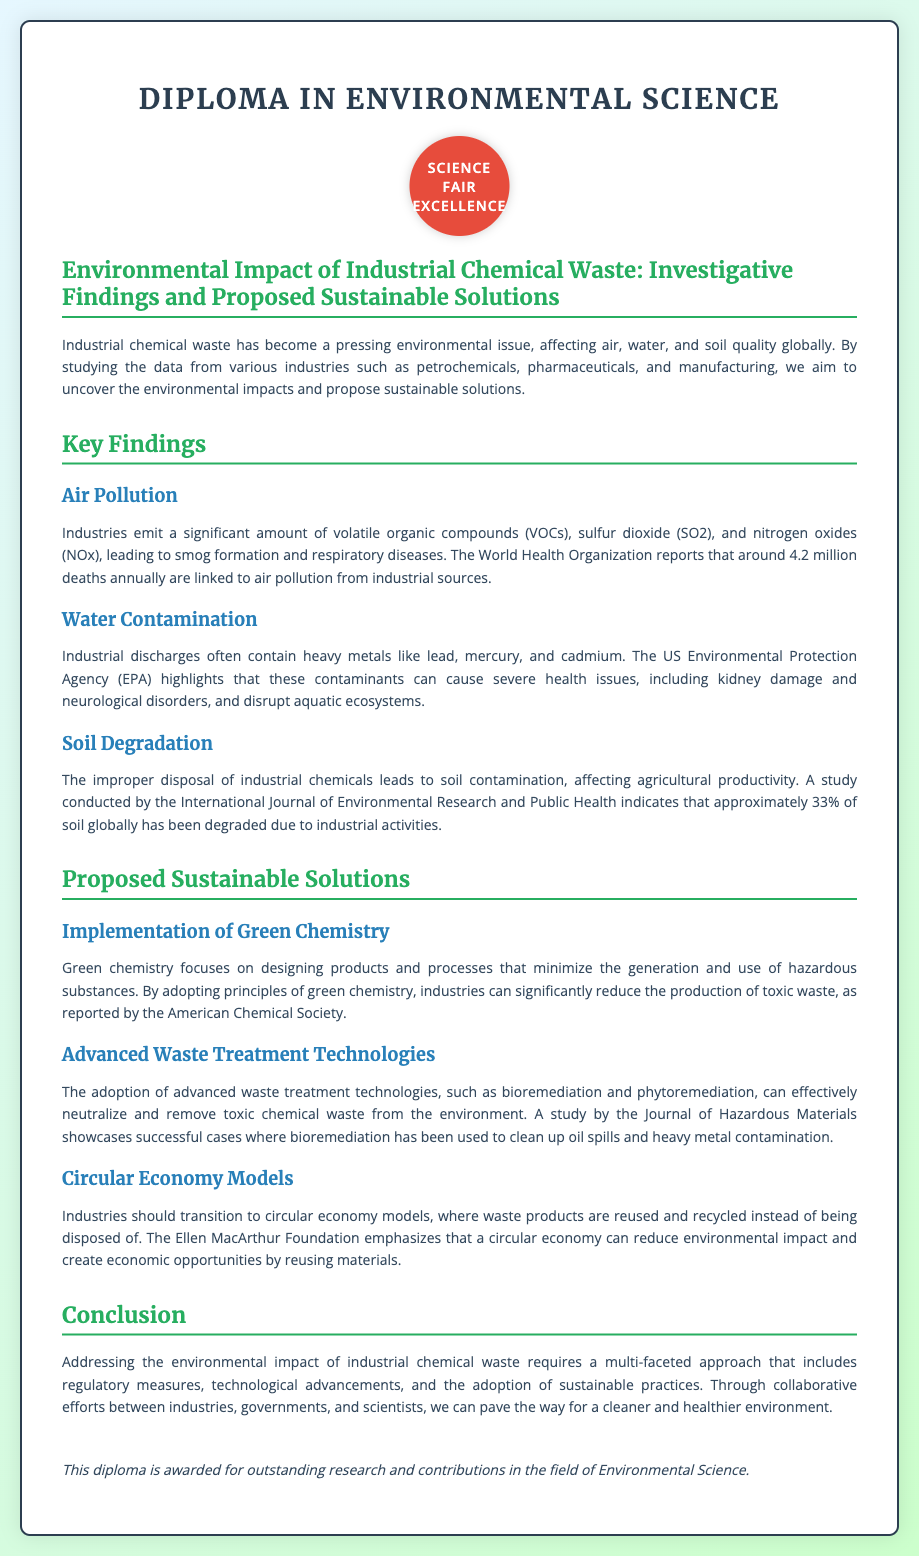what is the title of the diploma? The title of the diploma is mentioned at the beginning of the document, highlighting the focus of the research.
Answer: Environmental Impact of Industrial Chemical Waste: Investigative Findings and Proposed Sustainable Solutions how many deaths are linked to air pollution from industrial sources? The document states a specific number of deaths associated with air pollution based on data from the World Health Organization.
Answer: 4.2 million which heavy metals are mentioned as contaminants in water? The document lists specific heavy metals that are often found in industrial discharges affecting water quality.
Answer: lead, mercury, cadmium what percentage of soil globally has been degraded due to industrial activities? The document cites a study indicating the extent of soil degradation caused by industrial activities in terms of percentage.
Answer: 33% what is one proposed solution to reduce toxic waste? The document outlines different sustainable solutions, one of which focuses on changes in product design and processes.
Answer: Green chemistry which organization emphasizes the benefits of a circular economy? The document references an organization known for advocating sustainable economic practices, specifically related to waste management.
Answer: Ellen MacArthur Foundation what technique can effectively neutralize toxic chemical waste? The document mentions specific advanced technologies that help in treating industrial waste and making it safer.
Answer: Bioremediation what is the purpose of this diploma? The document concludes with a statement regarding the award of the diploma based on research contributions in a specific field.
Answer: Outstanding research and contributions in the field of Environmental Science 